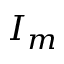Convert formula to latex. <formula><loc_0><loc_0><loc_500><loc_500>I _ { m }</formula> 